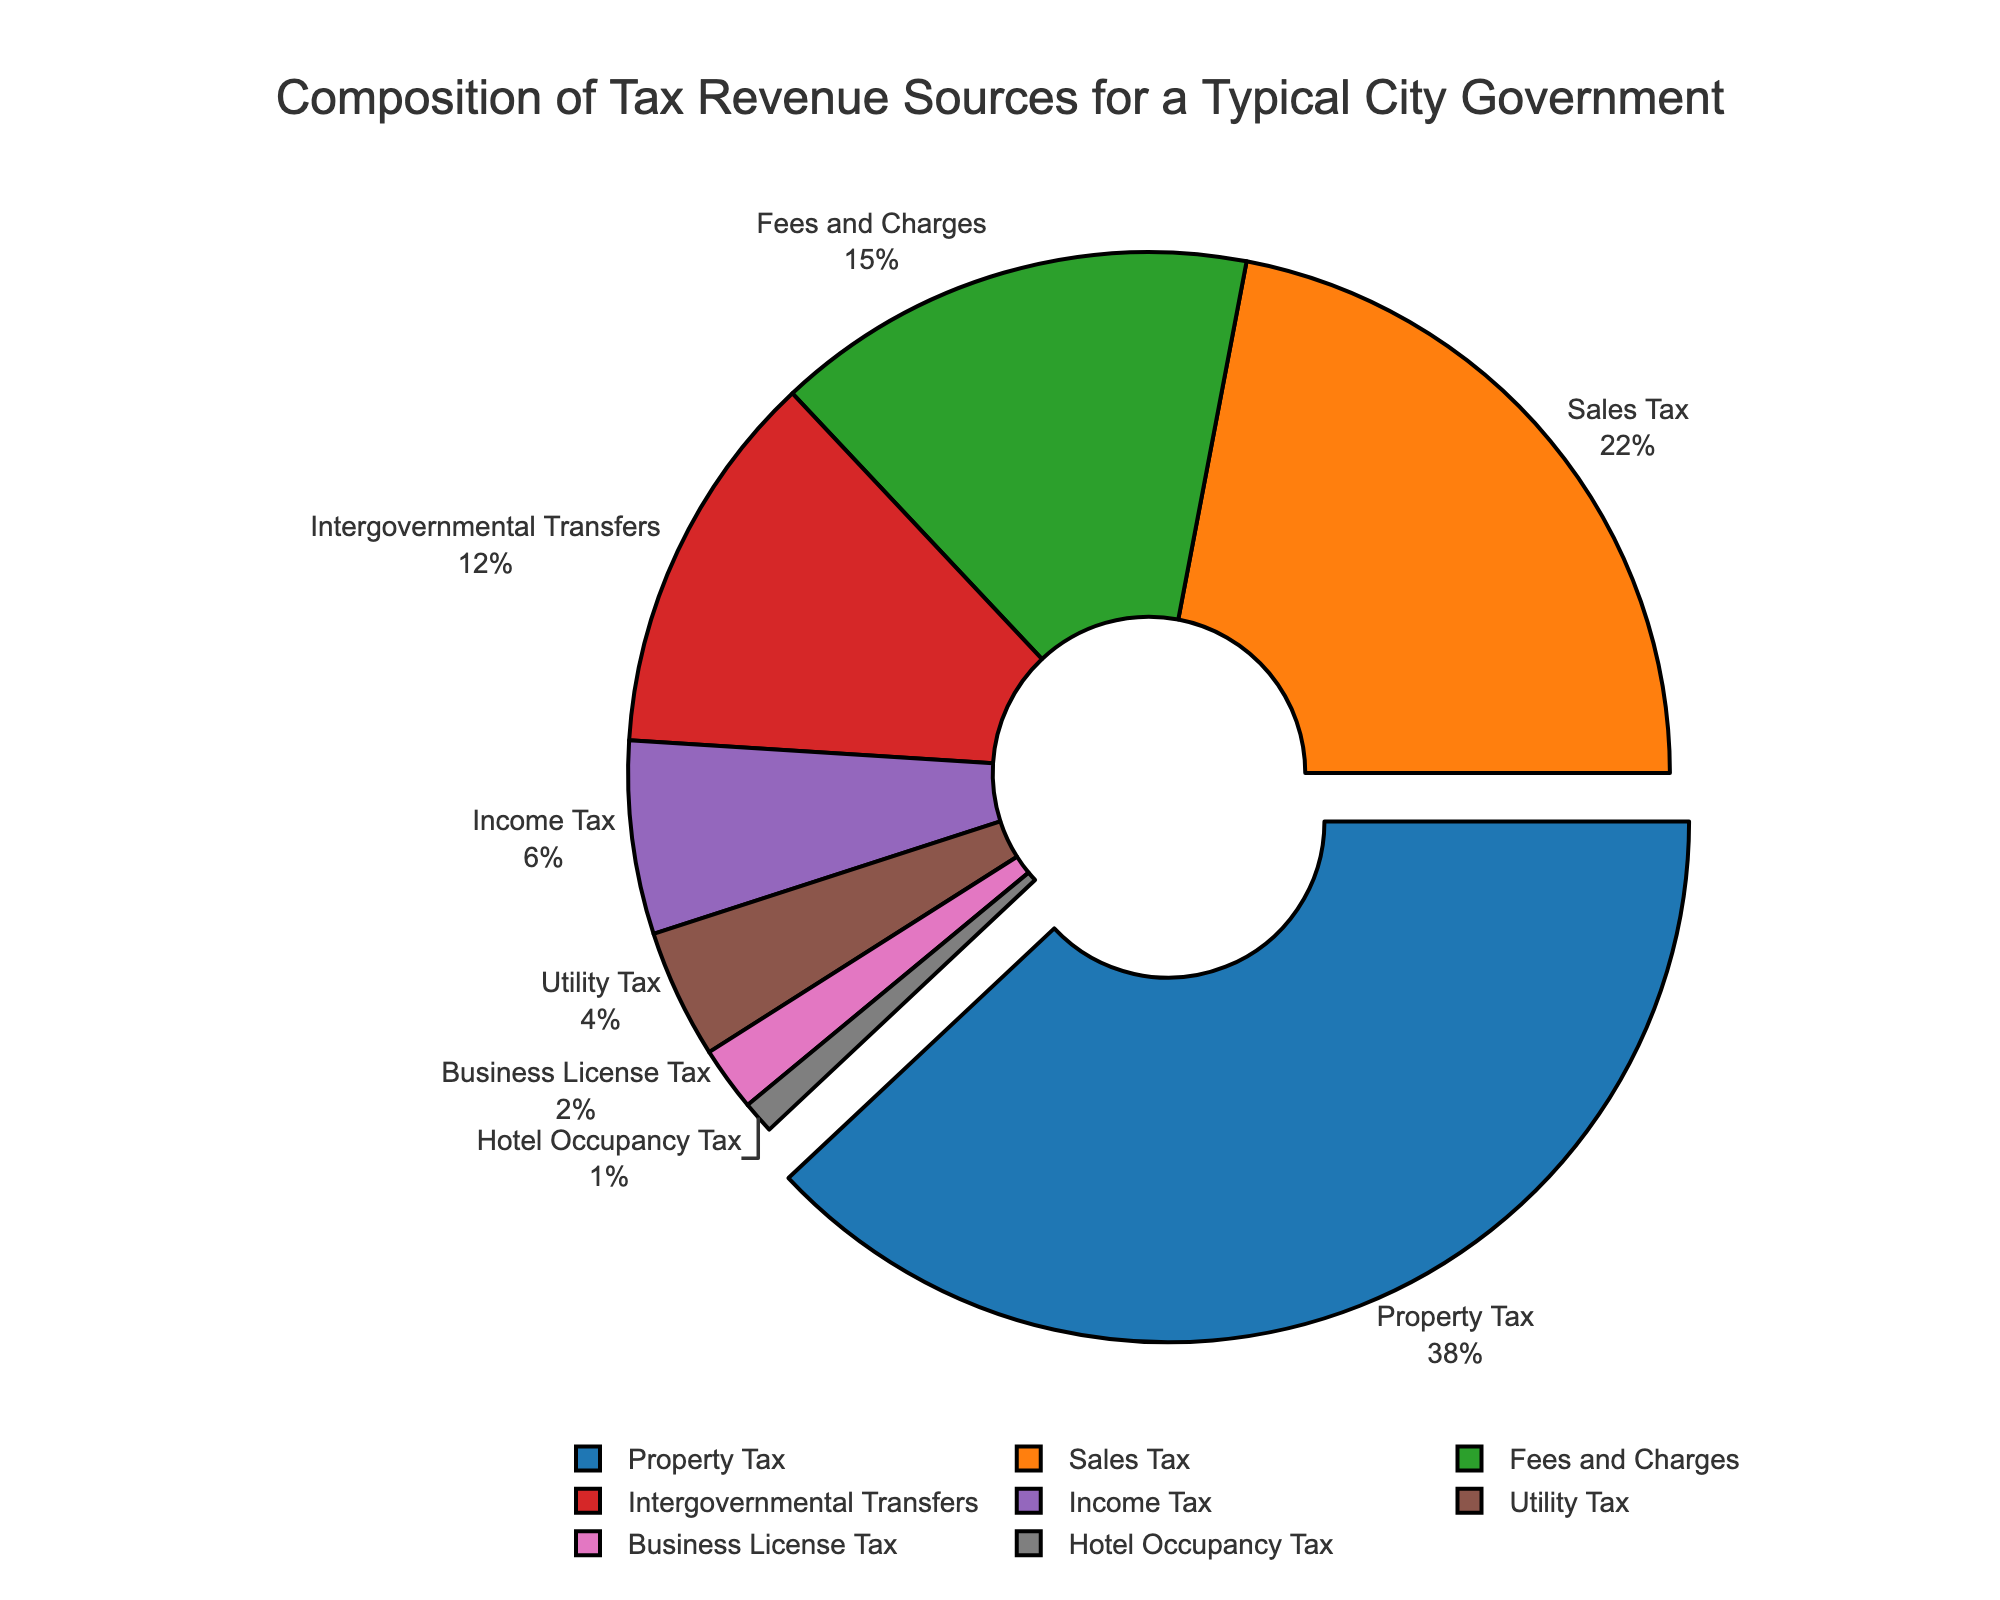What's the largest revenue source for the city government? The figure highlights the largest revenue source by pulling it out slightly from the pie chart. By inspecting this visual cue and the labeled percentages, we can identify the largest segment.
Answer: Property Tax What's the combined percentage of Sales Tax and Income Tax? First, note the individual percentages for Sales Tax (22%) and Income Tax (6%) from the figure. Then, sum these percentages: 22% + 6% = 28%.
Answer: 28% Which revenue source contributes the least, and what is its percentage? The figure includes percentages for all revenue sources. The smallest percentage visible is 1%, which corresponds to the Hotel Occupancy Tax.
Answer: Hotel Occupancy Tax, 1% How much more does Property Tax contribute compared to Utility Tax in percentage terms? Identify the percentages for Property Tax (38%) and Utility Tax (4%) from the figure. Calculate the difference: 38% - 4% = 34%.
Answer: 34% Is the combined contribution of Business License Tax and Hotel Occupancy Tax greater than Intergovernmental Transfers? First, sum the percentages for Business License Tax (2%) and Hotel Occupancy Tax (1%), giving 3%. Then, compare this to the percentage for Intergovernmental Transfers (12%): 3% < 12%.
Answer: No What is the total percentage contributed by fees-based revenue sources (Fees and Charges, Utility Tax, Business License Tax)? Sum the percentages for Fees and Charges (15%), Utility Tax (4%), and Business License Tax (2%): 15% + 4% + 2% = 21%.
Answer: 21% Which two revenue sources, when combined, contribute just over a third of the total tax revenue? Examine the figure and identify combinations of percentages. Property Tax (38%) alone is already over a third. Next, consider combining smaller sources:
Sales Tax (22%) + Fees and Charges (15%) = 37%. While this combination is close, the next largest combination would be Intergovernmental Transfers (12%) and Fees and Charges (15%) = 27%. Hence, only Property Tax (38%) alone fits best as over a third.
Answer: Property Tax, 38% What visual cue is used to emphasize the largest revenue source? Observe the pie chart; the largest revenue source, Property Tax, is slightly pulled out from the rest of the pie segments. This visual separation emphasizes its importance.
Answer: Pulled out segment Compare the contributions of Property Tax and Sales Tax. Which one is higher and by how much? From the figure, note the percentages for Property Tax (38%) and Sales Tax (22%). Calculate the difference: 38% - 22% = 16%.
Answer: Property Tax, 16% What is the average contribution of all revenue sources? There are eight revenue sources. Sum their contributions and divide by 8. The total sum is 
38 + 22 + 15 + 12 + 6 + 4 + 2 + 1 = 100%. So, the average is 100% / 8 = 12.5%.
Answer: 12.5% 